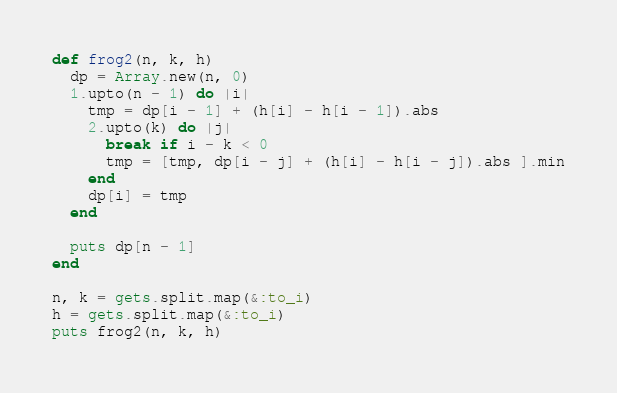<code> <loc_0><loc_0><loc_500><loc_500><_Ruby_>def frog2(n, k, h)
  dp = Array.new(n, 0)
  1.upto(n - 1) do |i|
    tmp = dp[i - 1] + (h[i] - h[i - 1]).abs
    2.upto(k) do |j|
      break if i - k < 0
      tmp = [tmp, dp[i - j] + (h[i] - h[i - j]).abs ].min
    end
    dp[i] = tmp
  end

  puts dp[n - 1]
end

n, k = gets.split.map(&:to_i)
h = gets.split.map(&:to_i)
puts frog2(n, k, h)</code> 